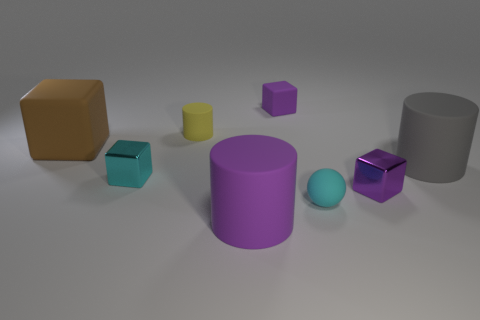Add 1 small yellow matte cylinders. How many objects exist? 9 Subtract all spheres. How many objects are left? 7 Subtract all tiny cyan shiny blocks. Subtract all small spheres. How many objects are left? 6 Add 3 cyan metallic cubes. How many cyan metallic cubes are left? 4 Add 2 purple rubber blocks. How many purple rubber blocks exist? 3 Subtract 0 green cubes. How many objects are left? 8 